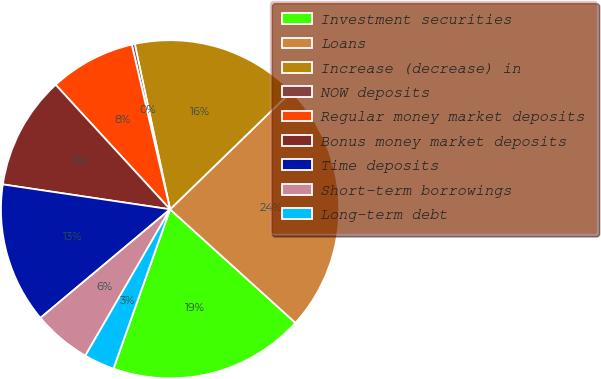Convert chart to OTSL. <chart><loc_0><loc_0><loc_500><loc_500><pie_chart><fcel>Investment securities<fcel>Loans<fcel>Increase (decrease) in<fcel>NOW deposits<fcel>Regular money market deposits<fcel>Bonus money market deposits<fcel>Time deposits<fcel>Short-term borrowings<fcel>Long-term debt<nl><fcel>18.72%<fcel>23.98%<fcel>16.08%<fcel>0.29%<fcel>8.19%<fcel>10.82%<fcel>13.45%<fcel>5.55%<fcel>2.92%<nl></chart> 